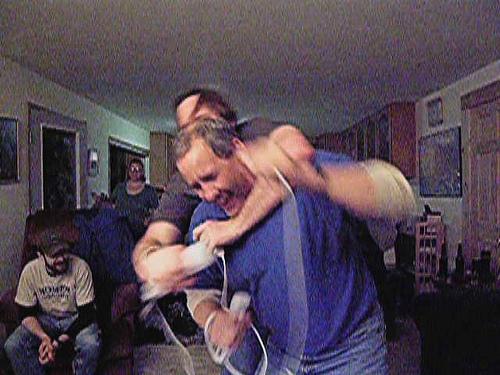What video game system are the men playing with?
Quick response, please. Wii. Is anyone wearing glasses?
Keep it brief. Yes. Do the men seem to be enjoying themselves?
Quick response, please. Yes. 